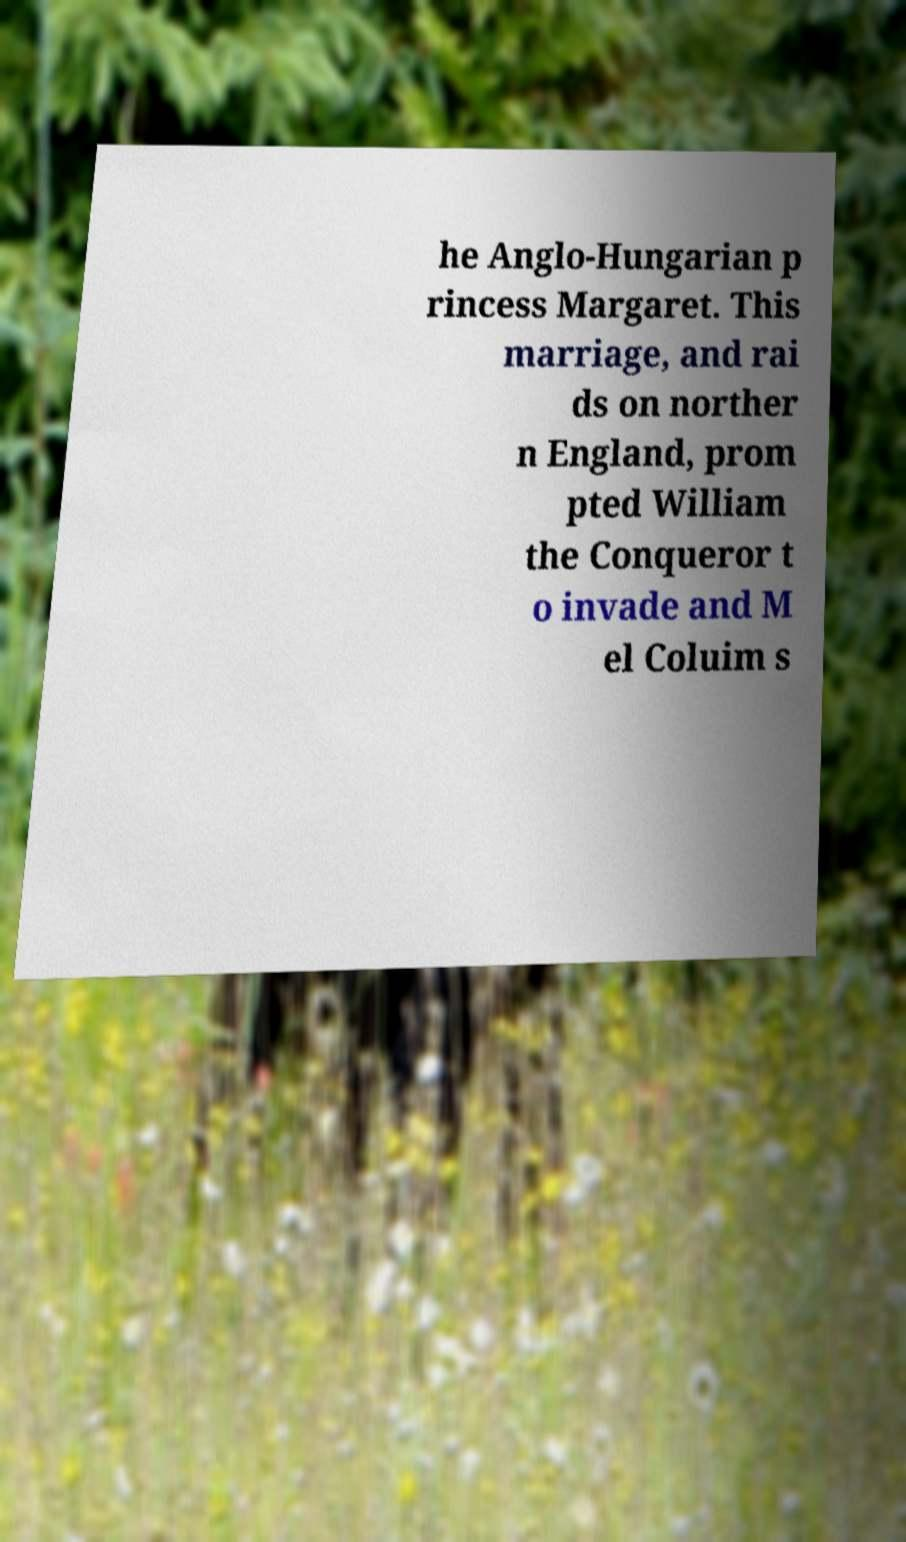There's text embedded in this image that I need extracted. Can you transcribe it verbatim? he Anglo-Hungarian p rincess Margaret. This marriage, and rai ds on norther n England, prom pted William the Conqueror t o invade and M el Coluim s 